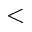<formula> <loc_0><loc_0><loc_500><loc_500><</formula> 